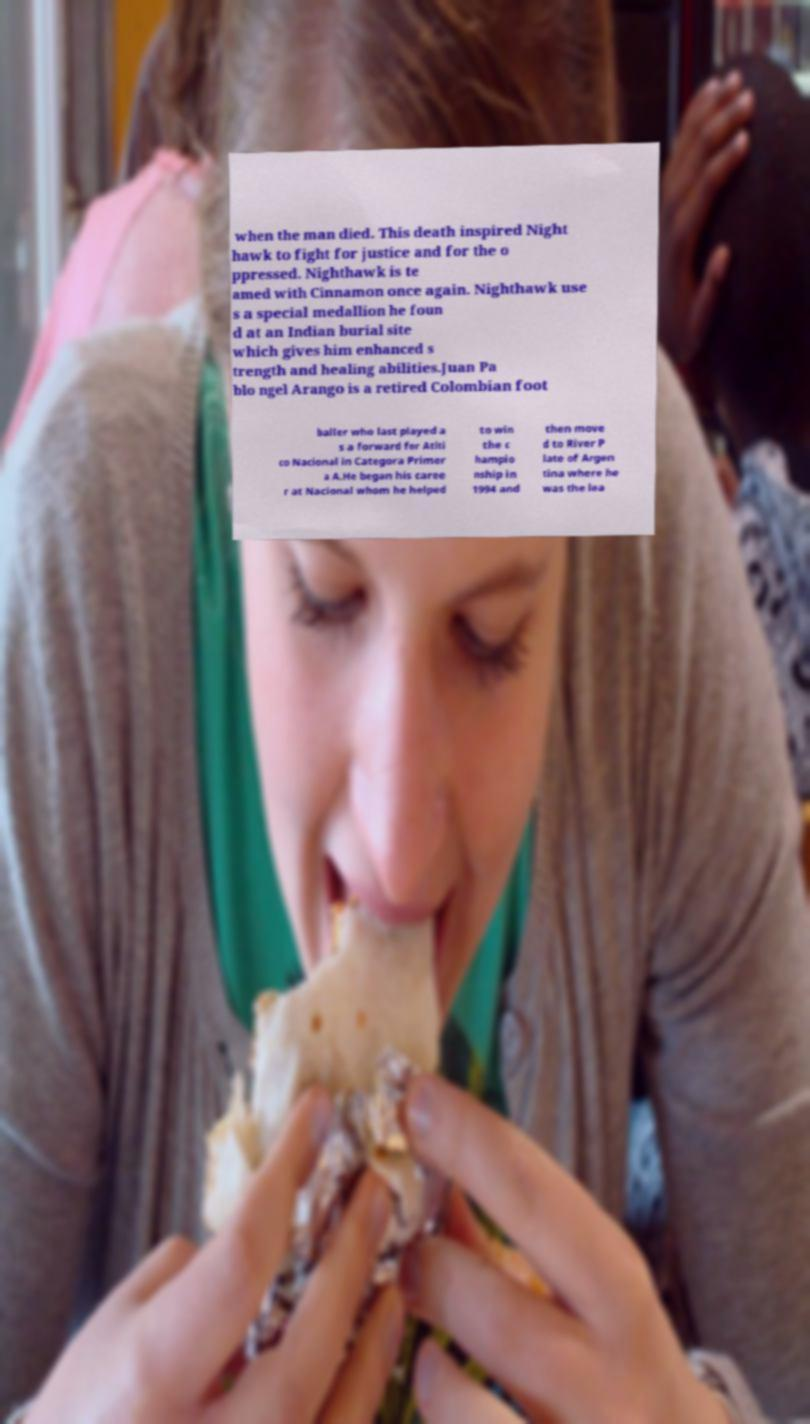I need the written content from this picture converted into text. Can you do that? when the man died. This death inspired Night hawk to fight for justice and for the o ppressed. Nighthawk is te amed with Cinnamon once again. Nighthawk use s a special medallion he foun d at an Indian burial site which gives him enhanced s trength and healing abilities.Juan Pa blo ngel Arango is a retired Colombian foot baller who last played a s a forward for Atlti co Nacional in Categora Primer a A.He began his caree r at Nacional whom he helped to win the c hampio nship in 1994 and then move d to River P late of Argen tina where he was the lea 